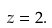Convert formula to latex. <formula><loc_0><loc_0><loc_500><loc_500>z = 2 .</formula> 